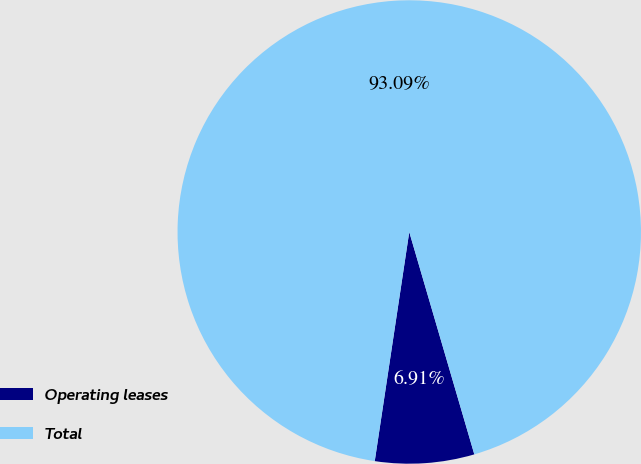Convert chart. <chart><loc_0><loc_0><loc_500><loc_500><pie_chart><fcel>Operating leases<fcel>Total<nl><fcel>6.91%<fcel>93.09%<nl></chart> 